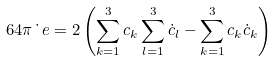<formula> <loc_0><loc_0><loc_500><loc_500>6 4 \pi \dot { \ } e = 2 \left ( \sum _ { k = 1 } ^ { 3 } c _ { k } \sum _ { l = 1 } ^ { 3 } \dot { c } _ { l } - \sum _ { k = 1 } ^ { 3 } c _ { k } \dot { c } _ { k } \right )</formula> 